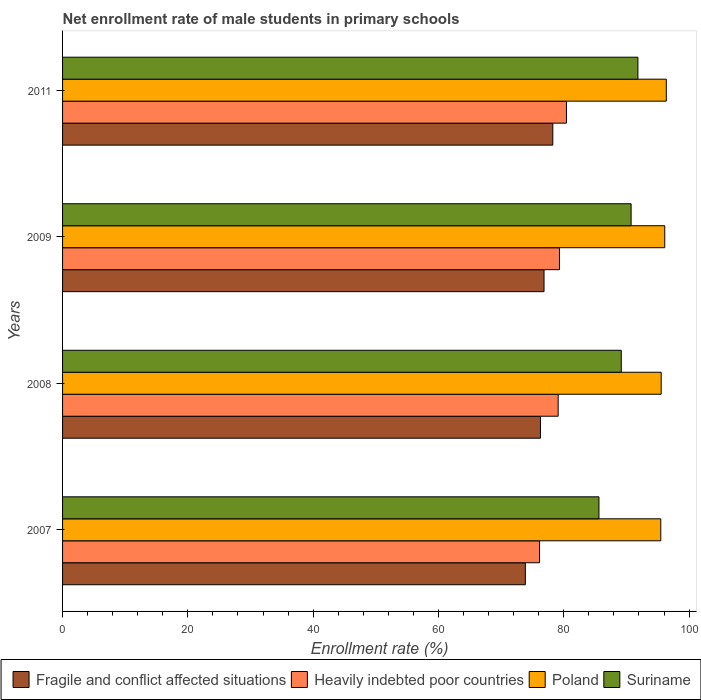How many different coloured bars are there?
Make the answer very short. 4. How many bars are there on the 1st tick from the top?
Keep it short and to the point. 4. What is the label of the 4th group of bars from the top?
Keep it short and to the point. 2007. What is the net enrollment rate of male students in primary schools in Suriname in 2008?
Ensure brevity in your answer.  89.18. Across all years, what is the maximum net enrollment rate of male students in primary schools in Fragile and conflict affected situations?
Offer a terse response. 78.25. Across all years, what is the minimum net enrollment rate of male students in primary schools in Suriname?
Give a very brief answer. 85.62. What is the total net enrollment rate of male students in primary schools in Poland in the graph?
Offer a very short reply. 383.52. What is the difference between the net enrollment rate of male students in primary schools in Fragile and conflict affected situations in 2007 and that in 2009?
Provide a succinct answer. -2.98. What is the difference between the net enrollment rate of male students in primary schools in Suriname in 2009 and the net enrollment rate of male students in primary schools in Fragile and conflict affected situations in 2008?
Your answer should be compact. 14.47. What is the average net enrollment rate of male students in primary schools in Heavily indebted poor countries per year?
Offer a very short reply. 78.75. In the year 2011, what is the difference between the net enrollment rate of male students in primary schools in Poland and net enrollment rate of male students in primary schools in Fragile and conflict affected situations?
Provide a short and direct response. 18.11. In how many years, is the net enrollment rate of male students in primary schools in Suriname greater than 16 %?
Your answer should be very brief. 4. What is the ratio of the net enrollment rate of male students in primary schools in Heavily indebted poor countries in 2008 to that in 2011?
Provide a succinct answer. 0.98. Is the difference between the net enrollment rate of male students in primary schools in Poland in 2008 and 2009 greater than the difference between the net enrollment rate of male students in primary schools in Fragile and conflict affected situations in 2008 and 2009?
Your answer should be compact. Yes. What is the difference between the highest and the second highest net enrollment rate of male students in primary schools in Fragile and conflict affected situations?
Provide a succinct answer. 1.4. What is the difference between the highest and the lowest net enrollment rate of male students in primary schools in Heavily indebted poor countries?
Provide a short and direct response. 4.3. In how many years, is the net enrollment rate of male students in primary schools in Suriname greater than the average net enrollment rate of male students in primary schools in Suriname taken over all years?
Offer a terse response. 2. Is it the case that in every year, the sum of the net enrollment rate of male students in primary schools in Poland and net enrollment rate of male students in primary schools in Fragile and conflict affected situations is greater than the sum of net enrollment rate of male students in primary schools in Suriname and net enrollment rate of male students in primary schools in Heavily indebted poor countries?
Ensure brevity in your answer.  Yes. What does the 1st bar from the top in 2007 represents?
Your response must be concise. Suriname. What does the 4th bar from the bottom in 2008 represents?
Ensure brevity in your answer.  Suriname. How many bars are there?
Keep it short and to the point. 16. What is the difference between two consecutive major ticks on the X-axis?
Give a very brief answer. 20. What is the title of the graph?
Ensure brevity in your answer.  Net enrollment rate of male students in primary schools. What is the label or title of the X-axis?
Ensure brevity in your answer.  Enrollment rate (%). What is the Enrollment rate (%) in Fragile and conflict affected situations in 2007?
Your response must be concise. 73.87. What is the Enrollment rate (%) of Heavily indebted poor countries in 2007?
Keep it short and to the point. 76.13. What is the Enrollment rate (%) of Poland in 2007?
Make the answer very short. 95.48. What is the Enrollment rate (%) of Suriname in 2007?
Make the answer very short. 85.62. What is the Enrollment rate (%) in Fragile and conflict affected situations in 2008?
Provide a short and direct response. 76.28. What is the Enrollment rate (%) of Heavily indebted poor countries in 2008?
Keep it short and to the point. 79.11. What is the Enrollment rate (%) of Poland in 2008?
Your answer should be compact. 95.55. What is the Enrollment rate (%) in Suriname in 2008?
Your answer should be compact. 89.18. What is the Enrollment rate (%) of Fragile and conflict affected situations in 2009?
Your response must be concise. 76.85. What is the Enrollment rate (%) of Heavily indebted poor countries in 2009?
Provide a short and direct response. 79.31. What is the Enrollment rate (%) of Poland in 2009?
Ensure brevity in your answer.  96.12. What is the Enrollment rate (%) in Suriname in 2009?
Keep it short and to the point. 90.75. What is the Enrollment rate (%) of Fragile and conflict affected situations in 2011?
Give a very brief answer. 78.25. What is the Enrollment rate (%) of Heavily indebted poor countries in 2011?
Ensure brevity in your answer.  80.43. What is the Enrollment rate (%) of Poland in 2011?
Keep it short and to the point. 96.37. What is the Enrollment rate (%) in Suriname in 2011?
Your answer should be compact. 91.84. Across all years, what is the maximum Enrollment rate (%) of Fragile and conflict affected situations?
Provide a succinct answer. 78.25. Across all years, what is the maximum Enrollment rate (%) of Heavily indebted poor countries?
Offer a terse response. 80.43. Across all years, what is the maximum Enrollment rate (%) in Poland?
Your response must be concise. 96.37. Across all years, what is the maximum Enrollment rate (%) in Suriname?
Give a very brief answer. 91.84. Across all years, what is the minimum Enrollment rate (%) of Fragile and conflict affected situations?
Provide a short and direct response. 73.87. Across all years, what is the minimum Enrollment rate (%) in Heavily indebted poor countries?
Make the answer very short. 76.13. Across all years, what is the minimum Enrollment rate (%) in Poland?
Offer a very short reply. 95.48. Across all years, what is the minimum Enrollment rate (%) of Suriname?
Provide a short and direct response. 85.62. What is the total Enrollment rate (%) of Fragile and conflict affected situations in the graph?
Your response must be concise. 305.25. What is the total Enrollment rate (%) of Heavily indebted poor countries in the graph?
Give a very brief answer. 314.98. What is the total Enrollment rate (%) of Poland in the graph?
Give a very brief answer. 383.52. What is the total Enrollment rate (%) of Suriname in the graph?
Give a very brief answer. 357.38. What is the difference between the Enrollment rate (%) in Fragile and conflict affected situations in 2007 and that in 2008?
Your response must be concise. -2.41. What is the difference between the Enrollment rate (%) of Heavily indebted poor countries in 2007 and that in 2008?
Ensure brevity in your answer.  -2.97. What is the difference between the Enrollment rate (%) in Poland in 2007 and that in 2008?
Provide a succinct answer. -0.07. What is the difference between the Enrollment rate (%) in Suriname in 2007 and that in 2008?
Keep it short and to the point. -3.56. What is the difference between the Enrollment rate (%) in Fragile and conflict affected situations in 2007 and that in 2009?
Provide a succinct answer. -2.98. What is the difference between the Enrollment rate (%) of Heavily indebted poor countries in 2007 and that in 2009?
Your response must be concise. -3.18. What is the difference between the Enrollment rate (%) in Poland in 2007 and that in 2009?
Your answer should be very brief. -0.63. What is the difference between the Enrollment rate (%) of Suriname in 2007 and that in 2009?
Make the answer very short. -5.13. What is the difference between the Enrollment rate (%) of Fragile and conflict affected situations in 2007 and that in 2011?
Ensure brevity in your answer.  -4.38. What is the difference between the Enrollment rate (%) of Heavily indebted poor countries in 2007 and that in 2011?
Provide a succinct answer. -4.29. What is the difference between the Enrollment rate (%) in Poland in 2007 and that in 2011?
Offer a terse response. -0.88. What is the difference between the Enrollment rate (%) in Suriname in 2007 and that in 2011?
Your answer should be very brief. -6.22. What is the difference between the Enrollment rate (%) in Fragile and conflict affected situations in 2008 and that in 2009?
Provide a succinct answer. -0.57. What is the difference between the Enrollment rate (%) of Heavily indebted poor countries in 2008 and that in 2009?
Provide a succinct answer. -0.21. What is the difference between the Enrollment rate (%) in Poland in 2008 and that in 2009?
Make the answer very short. -0.57. What is the difference between the Enrollment rate (%) in Suriname in 2008 and that in 2009?
Offer a terse response. -1.57. What is the difference between the Enrollment rate (%) of Fragile and conflict affected situations in 2008 and that in 2011?
Your response must be concise. -1.97. What is the difference between the Enrollment rate (%) in Heavily indebted poor countries in 2008 and that in 2011?
Keep it short and to the point. -1.32. What is the difference between the Enrollment rate (%) in Poland in 2008 and that in 2011?
Offer a very short reply. -0.82. What is the difference between the Enrollment rate (%) of Suriname in 2008 and that in 2011?
Provide a short and direct response. -2.66. What is the difference between the Enrollment rate (%) in Fragile and conflict affected situations in 2009 and that in 2011?
Ensure brevity in your answer.  -1.4. What is the difference between the Enrollment rate (%) of Heavily indebted poor countries in 2009 and that in 2011?
Make the answer very short. -1.12. What is the difference between the Enrollment rate (%) in Poland in 2009 and that in 2011?
Provide a short and direct response. -0.25. What is the difference between the Enrollment rate (%) of Suriname in 2009 and that in 2011?
Provide a succinct answer. -1.09. What is the difference between the Enrollment rate (%) of Fragile and conflict affected situations in 2007 and the Enrollment rate (%) of Heavily indebted poor countries in 2008?
Offer a very short reply. -5.24. What is the difference between the Enrollment rate (%) of Fragile and conflict affected situations in 2007 and the Enrollment rate (%) of Poland in 2008?
Your response must be concise. -21.68. What is the difference between the Enrollment rate (%) in Fragile and conflict affected situations in 2007 and the Enrollment rate (%) in Suriname in 2008?
Ensure brevity in your answer.  -15.31. What is the difference between the Enrollment rate (%) of Heavily indebted poor countries in 2007 and the Enrollment rate (%) of Poland in 2008?
Give a very brief answer. -19.42. What is the difference between the Enrollment rate (%) of Heavily indebted poor countries in 2007 and the Enrollment rate (%) of Suriname in 2008?
Make the answer very short. -13.04. What is the difference between the Enrollment rate (%) of Poland in 2007 and the Enrollment rate (%) of Suriname in 2008?
Ensure brevity in your answer.  6.31. What is the difference between the Enrollment rate (%) of Fragile and conflict affected situations in 2007 and the Enrollment rate (%) of Heavily indebted poor countries in 2009?
Keep it short and to the point. -5.44. What is the difference between the Enrollment rate (%) of Fragile and conflict affected situations in 2007 and the Enrollment rate (%) of Poland in 2009?
Keep it short and to the point. -22.25. What is the difference between the Enrollment rate (%) of Fragile and conflict affected situations in 2007 and the Enrollment rate (%) of Suriname in 2009?
Your response must be concise. -16.88. What is the difference between the Enrollment rate (%) in Heavily indebted poor countries in 2007 and the Enrollment rate (%) in Poland in 2009?
Offer a very short reply. -19.98. What is the difference between the Enrollment rate (%) in Heavily indebted poor countries in 2007 and the Enrollment rate (%) in Suriname in 2009?
Your answer should be compact. -14.62. What is the difference between the Enrollment rate (%) in Poland in 2007 and the Enrollment rate (%) in Suriname in 2009?
Keep it short and to the point. 4.74. What is the difference between the Enrollment rate (%) in Fragile and conflict affected situations in 2007 and the Enrollment rate (%) in Heavily indebted poor countries in 2011?
Offer a very short reply. -6.56. What is the difference between the Enrollment rate (%) of Fragile and conflict affected situations in 2007 and the Enrollment rate (%) of Poland in 2011?
Make the answer very short. -22.5. What is the difference between the Enrollment rate (%) in Fragile and conflict affected situations in 2007 and the Enrollment rate (%) in Suriname in 2011?
Your response must be concise. -17.97. What is the difference between the Enrollment rate (%) in Heavily indebted poor countries in 2007 and the Enrollment rate (%) in Poland in 2011?
Your answer should be compact. -20.23. What is the difference between the Enrollment rate (%) of Heavily indebted poor countries in 2007 and the Enrollment rate (%) of Suriname in 2011?
Offer a terse response. -15.7. What is the difference between the Enrollment rate (%) in Poland in 2007 and the Enrollment rate (%) in Suriname in 2011?
Provide a short and direct response. 3.65. What is the difference between the Enrollment rate (%) in Fragile and conflict affected situations in 2008 and the Enrollment rate (%) in Heavily indebted poor countries in 2009?
Offer a terse response. -3.03. What is the difference between the Enrollment rate (%) in Fragile and conflict affected situations in 2008 and the Enrollment rate (%) in Poland in 2009?
Provide a short and direct response. -19.84. What is the difference between the Enrollment rate (%) of Fragile and conflict affected situations in 2008 and the Enrollment rate (%) of Suriname in 2009?
Offer a terse response. -14.47. What is the difference between the Enrollment rate (%) of Heavily indebted poor countries in 2008 and the Enrollment rate (%) of Poland in 2009?
Keep it short and to the point. -17.01. What is the difference between the Enrollment rate (%) of Heavily indebted poor countries in 2008 and the Enrollment rate (%) of Suriname in 2009?
Your answer should be compact. -11.64. What is the difference between the Enrollment rate (%) in Poland in 2008 and the Enrollment rate (%) in Suriname in 2009?
Your response must be concise. 4.8. What is the difference between the Enrollment rate (%) in Fragile and conflict affected situations in 2008 and the Enrollment rate (%) in Heavily indebted poor countries in 2011?
Offer a terse response. -4.15. What is the difference between the Enrollment rate (%) in Fragile and conflict affected situations in 2008 and the Enrollment rate (%) in Poland in 2011?
Make the answer very short. -20.08. What is the difference between the Enrollment rate (%) in Fragile and conflict affected situations in 2008 and the Enrollment rate (%) in Suriname in 2011?
Provide a succinct answer. -15.55. What is the difference between the Enrollment rate (%) in Heavily indebted poor countries in 2008 and the Enrollment rate (%) in Poland in 2011?
Make the answer very short. -17.26. What is the difference between the Enrollment rate (%) in Heavily indebted poor countries in 2008 and the Enrollment rate (%) in Suriname in 2011?
Your response must be concise. -12.73. What is the difference between the Enrollment rate (%) of Poland in 2008 and the Enrollment rate (%) of Suriname in 2011?
Provide a succinct answer. 3.71. What is the difference between the Enrollment rate (%) of Fragile and conflict affected situations in 2009 and the Enrollment rate (%) of Heavily indebted poor countries in 2011?
Your answer should be compact. -3.58. What is the difference between the Enrollment rate (%) of Fragile and conflict affected situations in 2009 and the Enrollment rate (%) of Poland in 2011?
Provide a succinct answer. -19.52. What is the difference between the Enrollment rate (%) in Fragile and conflict affected situations in 2009 and the Enrollment rate (%) in Suriname in 2011?
Your answer should be very brief. -14.99. What is the difference between the Enrollment rate (%) in Heavily indebted poor countries in 2009 and the Enrollment rate (%) in Poland in 2011?
Keep it short and to the point. -17.05. What is the difference between the Enrollment rate (%) in Heavily indebted poor countries in 2009 and the Enrollment rate (%) in Suriname in 2011?
Give a very brief answer. -12.52. What is the difference between the Enrollment rate (%) of Poland in 2009 and the Enrollment rate (%) of Suriname in 2011?
Your answer should be compact. 4.28. What is the average Enrollment rate (%) of Fragile and conflict affected situations per year?
Your answer should be very brief. 76.31. What is the average Enrollment rate (%) in Heavily indebted poor countries per year?
Your answer should be compact. 78.75. What is the average Enrollment rate (%) in Poland per year?
Keep it short and to the point. 95.88. What is the average Enrollment rate (%) of Suriname per year?
Keep it short and to the point. 89.34. In the year 2007, what is the difference between the Enrollment rate (%) of Fragile and conflict affected situations and Enrollment rate (%) of Heavily indebted poor countries?
Make the answer very short. -2.27. In the year 2007, what is the difference between the Enrollment rate (%) of Fragile and conflict affected situations and Enrollment rate (%) of Poland?
Provide a succinct answer. -21.62. In the year 2007, what is the difference between the Enrollment rate (%) of Fragile and conflict affected situations and Enrollment rate (%) of Suriname?
Your answer should be compact. -11.75. In the year 2007, what is the difference between the Enrollment rate (%) of Heavily indebted poor countries and Enrollment rate (%) of Poland?
Your answer should be compact. -19.35. In the year 2007, what is the difference between the Enrollment rate (%) in Heavily indebted poor countries and Enrollment rate (%) in Suriname?
Your response must be concise. -9.48. In the year 2007, what is the difference between the Enrollment rate (%) in Poland and Enrollment rate (%) in Suriname?
Provide a short and direct response. 9.87. In the year 2008, what is the difference between the Enrollment rate (%) in Fragile and conflict affected situations and Enrollment rate (%) in Heavily indebted poor countries?
Provide a short and direct response. -2.83. In the year 2008, what is the difference between the Enrollment rate (%) in Fragile and conflict affected situations and Enrollment rate (%) in Poland?
Your response must be concise. -19.27. In the year 2008, what is the difference between the Enrollment rate (%) in Fragile and conflict affected situations and Enrollment rate (%) in Suriname?
Make the answer very short. -12.9. In the year 2008, what is the difference between the Enrollment rate (%) of Heavily indebted poor countries and Enrollment rate (%) of Poland?
Provide a succinct answer. -16.44. In the year 2008, what is the difference between the Enrollment rate (%) in Heavily indebted poor countries and Enrollment rate (%) in Suriname?
Ensure brevity in your answer.  -10.07. In the year 2008, what is the difference between the Enrollment rate (%) in Poland and Enrollment rate (%) in Suriname?
Give a very brief answer. 6.37. In the year 2009, what is the difference between the Enrollment rate (%) in Fragile and conflict affected situations and Enrollment rate (%) in Heavily indebted poor countries?
Provide a short and direct response. -2.46. In the year 2009, what is the difference between the Enrollment rate (%) of Fragile and conflict affected situations and Enrollment rate (%) of Poland?
Your answer should be compact. -19.27. In the year 2009, what is the difference between the Enrollment rate (%) of Fragile and conflict affected situations and Enrollment rate (%) of Suriname?
Give a very brief answer. -13.9. In the year 2009, what is the difference between the Enrollment rate (%) of Heavily indebted poor countries and Enrollment rate (%) of Poland?
Offer a very short reply. -16.81. In the year 2009, what is the difference between the Enrollment rate (%) in Heavily indebted poor countries and Enrollment rate (%) in Suriname?
Make the answer very short. -11.44. In the year 2009, what is the difference between the Enrollment rate (%) in Poland and Enrollment rate (%) in Suriname?
Provide a short and direct response. 5.37. In the year 2011, what is the difference between the Enrollment rate (%) of Fragile and conflict affected situations and Enrollment rate (%) of Heavily indebted poor countries?
Ensure brevity in your answer.  -2.18. In the year 2011, what is the difference between the Enrollment rate (%) of Fragile and conflict affected situations and Enrollment rate (%) of Poland?
Offer a very short reply. -18.11. In the year 2011, what is the difference between the Enrollment rate (%) in Fragile and conflict affected situations and Enrollment rate (%) in Suriname?
Provide a short and direct response. -13.58. In the year 2011, what is the difference between the Enrollment rate (%) in Heavily indebted poor countries and Enrollment rate (%) in Poland?
Your answer should be very brief. -15.94. In the year 2011, what is the difference between the Enrollment rate (%) in Heavily indebted poor countries and Enrollment rate (%) in Suriname?
Provide a short and direct response. -11.41. In the year 2011, what is the difference between the Enrollment rate (%) of Poland and Enrollment rate (%) of Suriname?
Offer a very short reply. 4.53. What is the ratio of the Enrollment rate (%) of Fragile and conflict affected situations in 2007 to that in 2008?
Ensure brevity in your answer.  0.97. What is the ratio of the Enrollment rate (%) of Heavily indebted poor countries in 2007 to that in 2008?
Your answer should be very brief. 0.96. What is the ratio of the Enrollment rate (%) in Poland in 2007 to that in 2008?
Provide a succinct answer. 1. What is the ratio of the Enrollment rate (%) in Suriname in 2007 to that in 2008?
Make the answer very short. 0.96. What is the ratio of the Enrollment rate (%) of Fragile and conflict affected situations in 2007 to that in 2009?
Ensure brevity in your answer.  0.96. What is the ratio of the Enrollment rate (%) of Heavily indebted poor countries in 2007 to that in 2009?
Your answer should be compact. 0.96. What is the ratio of the Enrollment rate (%) of Poland in 2007 to that in 2009?
Provide a short and direct response. 0.99. What is the ratio of the Enrollment rate (%) of Suriname in 2007 to that in 2009?
Provide a succinct answer. 0.94. What is the ratio of the Enrollment rate (%) of Fragile and conflict affected situations in 2007 to that in 2011?
Your answer should be compact. 0.94. What is the ratio of the Enrollment rate (%) of Heavily indebted poor countries in 2007 to that in 2011?
Your answer should be compact. 0.95. What is the ratio of the Enrollment rate (%) of Suriname in 2007 to that in 2011?
Your response must be concise. 0.93. What is the ratio of the Enrollment rate (%) in Heavily indebted poor countries in 2008 to that in 2009?
Ensure brevity in your answer.  1. What is the ratio of the Enrollment rate (%) of Poland in 2008 to that in 2009?
Provide a succinct answer. 0.99. What is the ratio of the Enrollment rate (%) in Suriname in 2008 to that in 2009?
Make the answer very short. 0.98. What is the ratio of the Enrollment rate (%) of Fragile and conflict affected situations in 2008 to that in 2011?
Offer a terse response. 0.97. What is the ratio of the Enrollment rate (%) of Heavily indebted poor countries in 2008 to that in 2011?
Your response must be concise. 0.98. What is the ratio of the Enrollment rate (%) in Suriname in 2008 to that in 2011?
Ensure brevity in your answer.  0.97. What is the ratio of the Enrollment rate (%) in Fragile and conflict affected situations in 2009 to that in 2011?
Give a very brief answer. 0.98. What is the ratio of the Enrollment rate (%) in Heavily indebted poor countries in 2009 to that in 2011?
Provide a short and direct response. 0.99. What is the ratio of the Enrollment rate (%) of Poland in 2009 to that in 2011?
Offer a terse response. 1. What is the ratio of the Enrollment rate (%) in Suriname in 2009 to that in 2011?
Your response must be concise. 0.99. What is the difference between the highest and the second highest Enrollment rate (%) of Fragile and conflict affected situations?
Keep it short and to the point. 1.4. What is the difference between the highest and the second highest Enrollment rate (%) of Heavily indebted poor countries?
Your response must be concise. 1.12. What is the difference between the highest and the second highest Enrollment rate (%) of Poland?
Your answer should be compact. 0.25. What is the difference between the highest and the second highest Enrollment rate (%) of Suriname?
Offer a terse response. 1.09. What is the difference between the highest and the lowest Enrollment rate (%) in Fragile and conflict affected situations?
Keep it short and to the point. 4.38. What is the difference between the highest and the lowest Enrollment rate (%) of Heavily indebted poor countries?
Provide a succinct answer. 4.29. What is the difference between the highest and the lowest Enrollment rate (%) of Poland?
Provide a succinct answer. 0.88. What is the difference between the highest and the lowest Enrollment rate (%) of Suriname?
Provide a succinct answer. 6.22. 